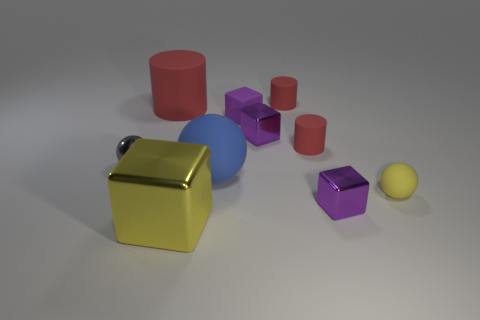What number of things are spheres behind the small yellow matte thing or big cyan metal things?
Offer a terse response. 2. What is the material of the red thing that is the same size as the blue rubber object?
Offer a terse response. Rubber. There is a tiny cylinder that is in front of the matte thing that is behind the big red thing; what color is it?
Your response must be concise. Red. What number of gray spheres are in front of the big shiny thing?
Offer a very short reply. 0. What is the color of the matte cube?
Your response must be concise. Purple. What number of tiny things are either yellow metal spheres or blocks?
Make the answer very short. 3. Does the tiny matte cylinder that is in front of the tiny purple rubber object have the same color as the large matte object that is behind the blue thing?
Give a very brief answer. Yes. What number of other objects are there of the same color as the big matte cylinder?
Make the answer very short. 2. The tiny purple matte thing on the right side of the small gray thing has what shape?
Give a very brief answer. Cube. Is the number of tiny brown metal spheres less than the number of red objects?
Provide a succinct answer. Yes. 